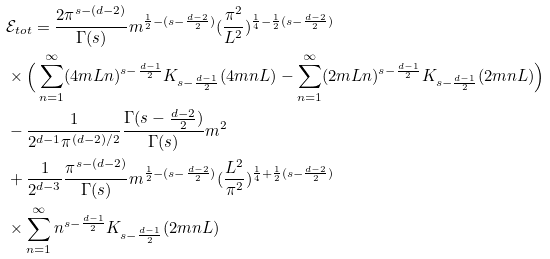<formula> <loc_0><loc_0><loc_500><loc_500>& \mathcal { E } _ { t o t } = \frac { 2 \pi ^ { s - ( d - 2 ) } } { \Gamma ( s ) } m ^ { \frac { 1 } { 2 } - ( s - \frac { d - 2 } { 2 } ) } ( \frac { \pi ^ { 2 } } { L ^ { 2 } } ) ^ { \frac { 1 } { 4 } - \frac { 1 } { 2 } ( s - \frac { d - 2 } { 2 } ) } \\ & \times \Big { ( } \sum _ { n = 1 } ^ { \infty } ( 4 m L n ) ^ { s - \frac { d - 1 } { 2 } } K _ { s - \frac { d - 1 } { 2 } } ( 4 m n L ) - \sum _ { n = 1 } ^ { \infty } ( 2 m L n ) ^ { s - \frac { d - 1 } { 2 } } K _ { s - \frac { d - 1 } { 2 } } ( 2 m n L ) \Big { ) } \\ & - \frac { 1 } { 2 ^ { d - 1 } \pi ^ { ( d - 2 ) / 2 } } \frac { \Gamma ( s - \frac { d - 2 } { 2 } ) } { \Gamma ( s ) } m ^ { 2 } \\ & + \frac { 1 } { 2 ^ { d - 3 } } \frac { \pi ^ { s - ( d - 2 ) } } { \Gamma ( s ) } m ^ { \frac { 1 } { 2 } - ( s - \frac { d - 2 } { 2 } ) } ( \frac { L ^ { 2 } } { \pi ^ { 2 } } ) ^ { \frac { 1 } { 4 } + \frac { 1 } { 2 } ( s - \frac { d - 2 } { 2 } ) } \\ & \times \sum _ { n = 1 } ^ { \infty } n ^ { s - \frac { d - 1 } { 2 } } K _ { s - \frac { d - 1 } { 2 } } ( 2 m n L )</formula> 